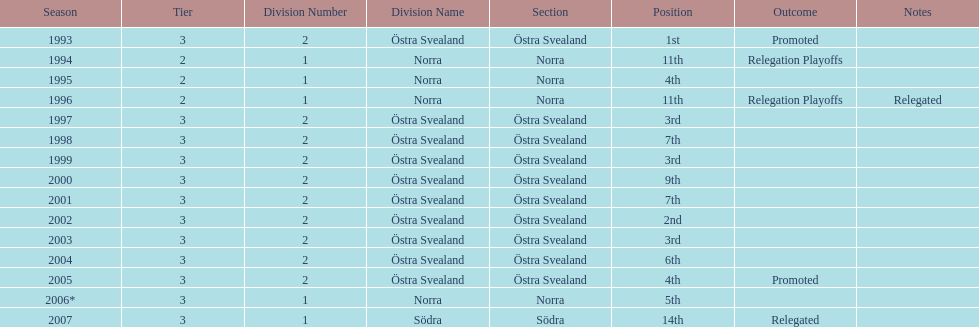Would you be able to parse every entry in this table? {'header': ['Season', 'Tier', 'Division Number', 'Division Name', 'Section', 'Position', 'Outcome', 'Notes'], 'rows': [['1993', '3', '2', 'Östra Svealand', 'Östra Svealand', '1st', 'Promoted', ''], ['1994', '2', '1', 'Norra', 'Norra', '11th', 'Relegation Playoffs', ''], ['1995', '2', '1', 'Norra', 'Norra', '4th', '', ''], ['1996', '2', '1', 'Norra', 'Norra', '11th', 'Relegation Playoffs', 'Relegated'], ['1997', '3', '2', 'Östra Svealand', 'Östra Svealand', '3rd', '', ''], ['1998', '3', '2', 'Östra Svealand', 'Östra Svealand', '7th', '', ''], ['1999', '3', '2', 'Östra Svealand', 'Östra Svealand', '3rd', '', ''], ['2000', '3', '2', 'Östra Svealand', 'Östra Svealand', '9th', '', ''], ['2001', '3', '2', 'Östra Svealand', 'Östra Svealand', '7th', '', ''], ['2002', '3', '2', 'Östra Svealand', 'Östra Svealand', '2nd', '', ''], ['2003', '3', '2', 'Östra Svealand', 'Östra Svealand', '3rd', '', ''], ['2004', '3', '2', 'Östra Svealand', 'Östra Svealand', '6th', '', ''], ['2005', '3', '2', 'Östra Svealand', 'Östra Svealand', '4th', 'Promoted', ''], ['2006*', '3', '1', 'Norra', 'Norra', '5th', '', ''], ['2007', '3', '1', 'Södra', 'Södra', '14th', 'Relegated', '']]} What year was their top performance? 1993. 